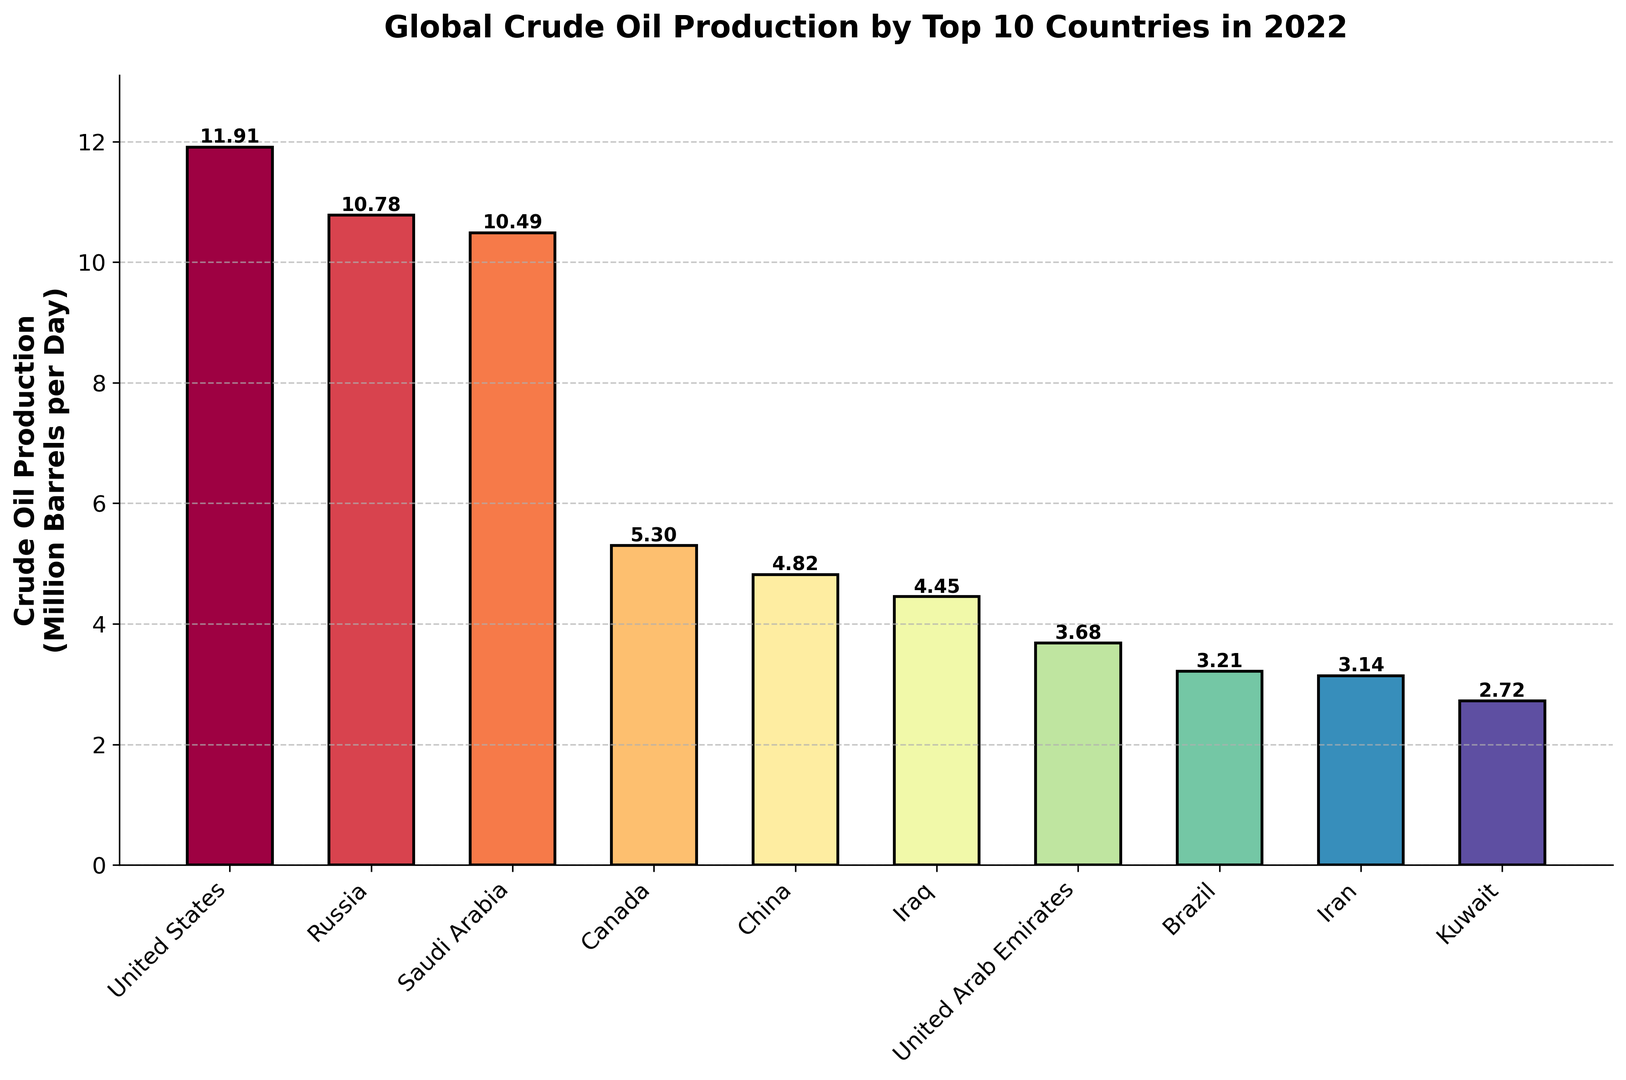Which country has the highest crude oil production? The country with the highest bar corresponds to the highest crude oil production. From the graph, the United States has the highest bar.
Answer: United States What's the total crude oil production of the top 3 countries combined? Identify the top 3 countries by highest production which are the United States, Russia, and Saudi Arabia. Sum their production values: 11.91 (US) + 10.78 (Russia) + 10.49 (Saudi Arabia) = 33.18
Answer: 33.18 Which country produces more crude oil, Brazil or Iran? Compare the heights of the bars for Brazil and Iran. Brazil has a higher bar than Iran.
Answer: Brazil What is the crude oil production difference between the United States and Russia? Subtract Russia's production from the United States' production: 11.91 (US) - 10.78 (Russia) = 1.13
Answer: 1.13 Which countries produce less than 4 million barrels per day? Identify the countries with bars lower than the 4 million mark. They are the United Arab Emirates, Brazil, Iran, and Kuwait.
Answer: United Arab Emirates, Brazil, Iran, Kuwait What is the average crude oil production of the top 5 countries? Sum the production values of the top 5 countries: 11.91 + 10.78 + 10.49 + 5.30 + 4.82 = 43.3. Divide by 5: 43.3 / 5 = 8.66
Answer: 8.66 Which country has the lowest crude oil production? The country with the shortest bar corresponds to the lowest crude oil production. From the graph, Kuwait has the lowest bar.
Answer: Kuwait What is the combined crude oil production of the countries in the Middle East? Sum the production values for Saudi Arabia, Iraq, United Arab Emirates, Iran, and Kuwait: 10.49 + 4.45 + 3.68 + 3.14 + 2.72 = 24.48
Answer: 24.48 Is China's crude oil production more or less than Canada? Compare the heights of the bars for China and Canada. China's bar is shorter than Canada's.
Answer: Less How many countries produce between 3 and 5 million barrels per day? Count the number of countries within the bar height range of 3 to 5 million. The countries are China, Iraq, United Arab Emirates, Brazil, and Iran.
Answer: 5 